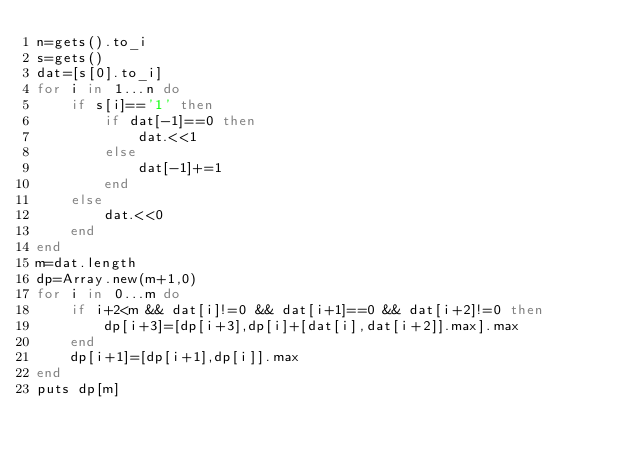Convert code to text. <code><loc_0><loc_0><loc_500><loc_500><_Ruby_>n=gets().to_i
s=gets()
dat=[s[0].to_i]
for i in 1...n do
    if s[i]=='1' then
        if dat[-1]==0 then
            dat.<<1
        else
            dat[-1]+=1
        end
    else
        dat.<<0
    end
end
m=dat.length
dp=Array.new(m+1,0)
for i in 0...m do
    if i+2<m && dat[i]!=0 && dat[i+1]==0 && dat[i+2]!=0 then
        dp[i+3]=[dp[i+3],dp[i]+[dat[i],dat[i+2]].max].max
    end
    dp[i+1]=[dp[i+1],dp[i]].max
end
puts dp[m]</code> 